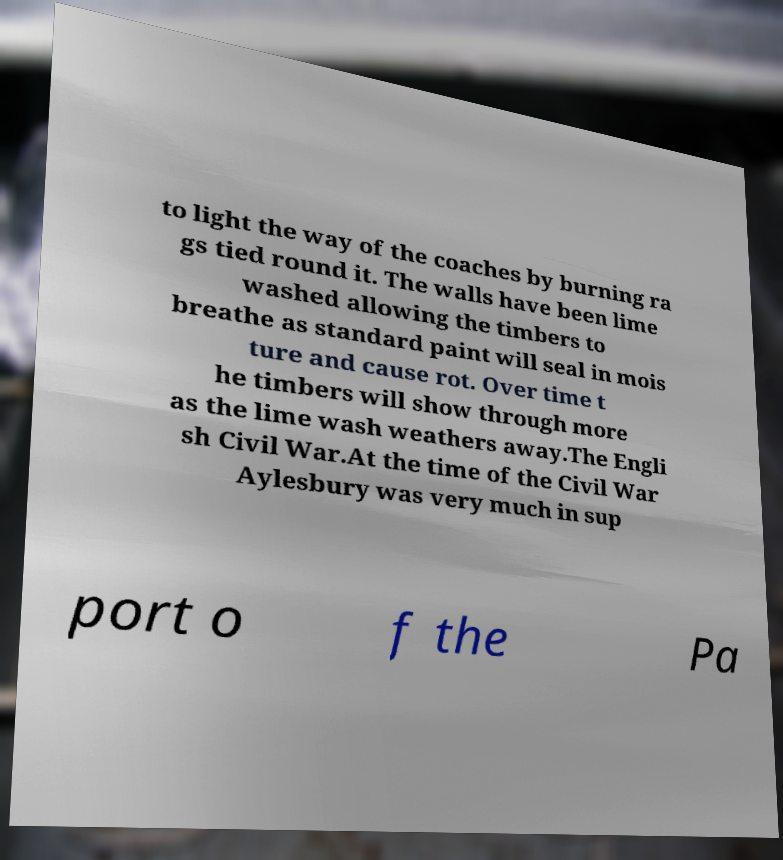Could you assist in decoding the text presented in this image and type it out clearly? to light the way of the coaches by burning ra gs tied round it. The walls have been lime washed allowing the timbers to breathe as standard paint will seal in mois ture and cause rot. Over time t he timbers will show through more as the lime wash weathers away.The Engli sh Civil War.At the time of the Civil War Aylesbury was very much in sup port o f the Pa 